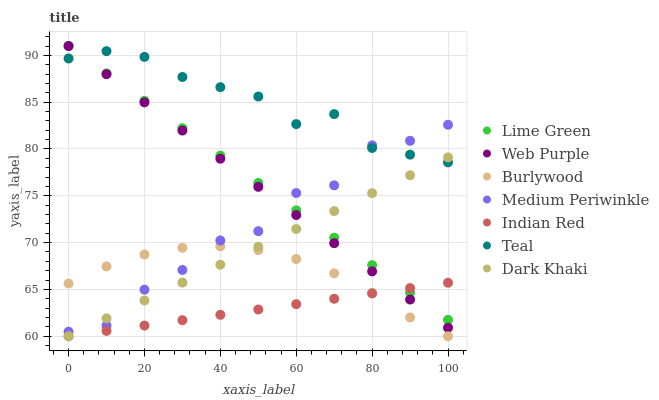Does Indian Red have the minimum area under the curve?
Answer yes or no. Yes. Does Teal have the maximum area under the curve?
Answer yes or no. Yes. Does Burlywood have the minimum area under the curve?
Answer yes or no. No. Does Burlywood have the maximum area under the curve?
Answer yes or no. No. Is Indian Red the smoothest?
Answer yes or no. Yes. Is Medium Periwinkle the roughest?
Answer yes or no. Yes. Is Burlywood the smoothest?
Answer yes or no. No. Is Burlywood the roughest?
Answer yes or no. No. Does Indian Red have the lowest value?
Answer yes or no. Yes. Does Medium Periwinkle have the lowest value?
Answer yes or no. No. Does Lime Green have the highest value?
Answer yes or no. Yes. Does Burlywood have the highest value?
Answer yes or no. No. Is Burlywood less than Web Purple?
Answer yes or no. Yes. Is Web Purple greater than Burlywood?
Answer yes or no. Yes. Does Web Purple intersect Indian Red?
Answer yes or no. Yes. Is Web Purple less than Indian Red?
Answer yes or no. No. Is Web Purple greater than Indian Red?
Answer yes or no. No. Does Burlywood intersect Web Purple?
Answer yes or no. No. 